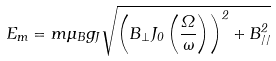<formula> <loc_0><loc_0><loc_500><loc_500>E _ { m } = m \mu _ { B } g _ { J } \sqrt { \left ( B _ { \perp } J _ { 0 } \left ( \frac { \Omega } { \omega } \right ) \right ) ^ { 2 } + B _ { / / } ^ { 2 } }</formula> 